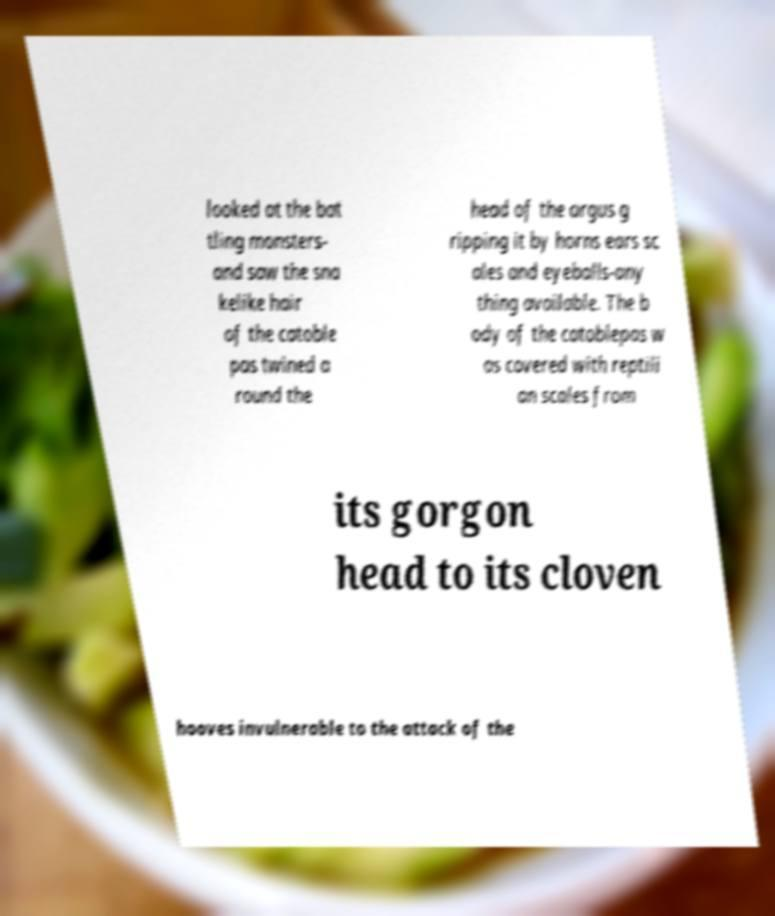What messages or text are displayed in this image? I need them in a readable, typed format. looked at the bat tling monsters- and saw the sna kelike hair of the catoble pas twined a round the head of the argus g ripping it by horns ears sc ales and eyeballs-any thing available. The b ody of the catoblepas w as covered with reptili an scales from its gorgon head to its cloven hooves invulnerable to the attack of the 